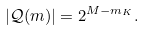Convert formula to latex. <formula><loc_0><loc_0><loc_500><loc_500>| \mathcal { Q } ( m ) | = 2 ^ { M - m _ { K } } .</formula> 